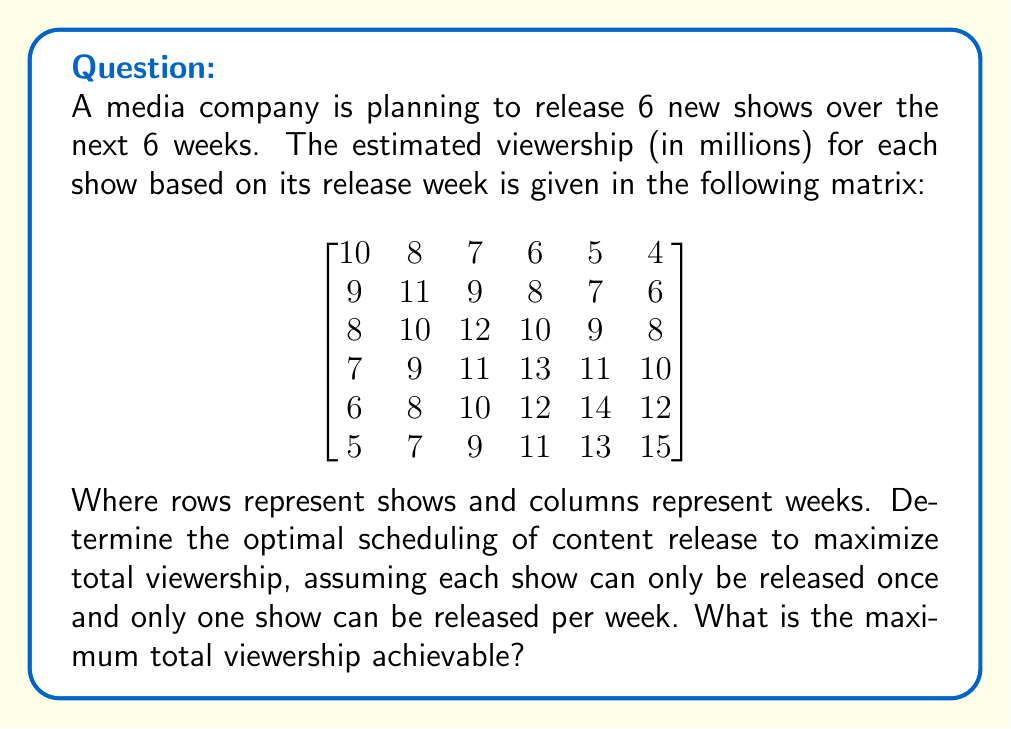Show me your answer to this math problem. This problem can be solved using the Hungarian algorithm, which is an optimization algorithm for assignment problems. Here's a step-by-step approach:

1) First, we need to convert this maximization problem into a minimization problem. We can do this by subtracting each element from the maximum value in the matrix (15):

$$
\begin{bmatrix}
5 & 7 & 8 & 9 & 10 & 11 \\
6 & 4 & 6 & 7 & 8 & 9 \\
7 & 5 & 3 & 5 & 6 & 7 \\
8 & 6 & 4 & 2 & 4 & 5 \\
9 & 7 & 5 & 3 & 1 & 3 \\
10 & 8 & 6 & 4 & 2 & 0
\end{bmatrix}
$$

2) Now we apply the Hungarian algorithm:

   a) Subtract the smallest element in each row from all elements in that row:

   $$
   \begin{bmatrix}
   0 & 2 & 3 & 4 & 5 & 6 \\
   2 & 0 & 2 & 3 & 4 & 5 \\
   4 & 2 & 0 & 2 & 3 & 4 \\
   6 & 4 & 2 & 0 & 2 & 3 \\
   8 & 6 & 4 & 2 & 0 & 2 \\
   10 & 8 & 6 & 4 & 2 & 0
   \end{bmatrix}
   $$

   b) Subtract the smallest element in each column from all elements in that column:

   $$
   \begin{bmatrix}
   0 & 2 & 3 & 4 & 5 & 6 \\
   2 & 0 & 2 & 3 & 4 & 5 \\
   4 & 2 & 0 & 2 & 3 & 4 \\
   6 & 4 & 2 & 0 & 2 & 3 \\
   8 & 6 & 4 & 2 & 0 & 2 \\
   10 & 8 & 6 & 4 & 2 & 0
   \end{bmatrix}
   $$

3) We can now make assignments. The optimal assignment is:
   - Show 1 to Week 1
   - Show 2 to Week 2
   - Show 3 to Week 3
   - Show 4 to Week 4
   - Show 5 to Week 5
   - Show 6 to Week 6

4) To calculate the total viewership, we sum the corresponding values from the original matrix:

   10 + 11 + 12 + 13 + 14 + 15 = 75

Therefore, the maximum total viewership achievable is 75 million.
Answer: 75 million viewers 